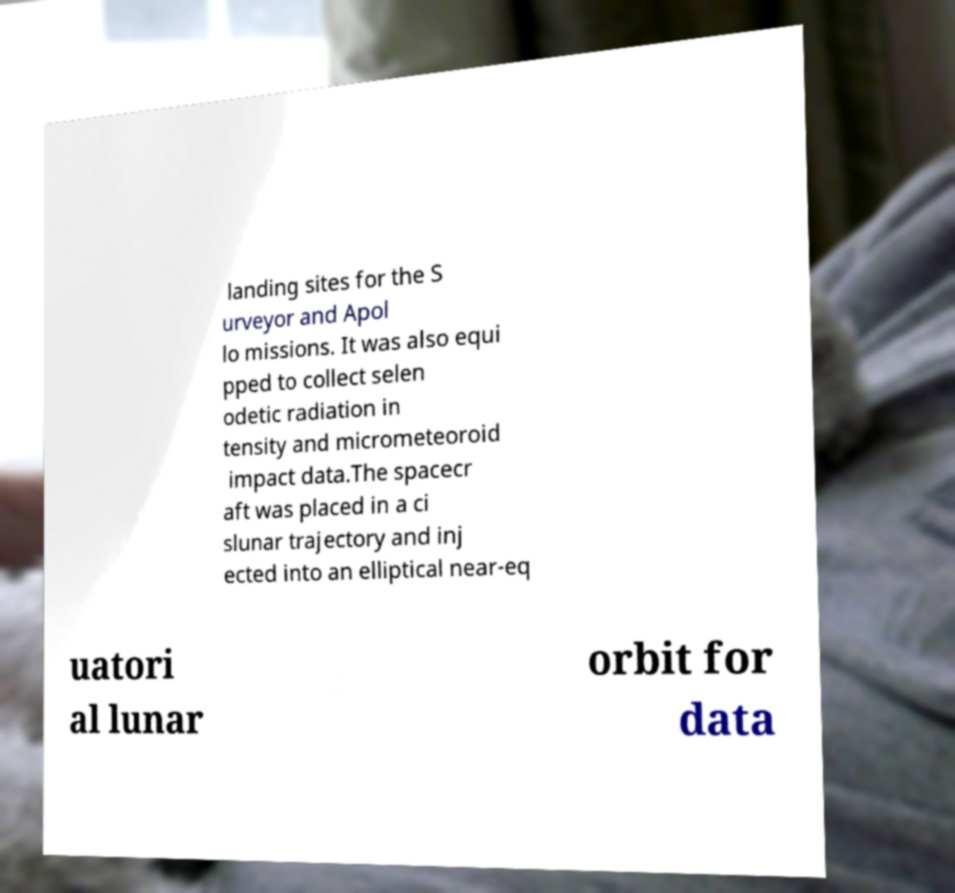Please identify and transcribe the text found in this image. landing sites for the S urveyor and Apol lo missions. It was also equi pped to collect selen odetic radiation in tensity and micrometeoroid impact data.The spacecr aft was placed in a ci slunar trajectory and inj ected into an elliptical near-eq uatori al lunar orbit for data 